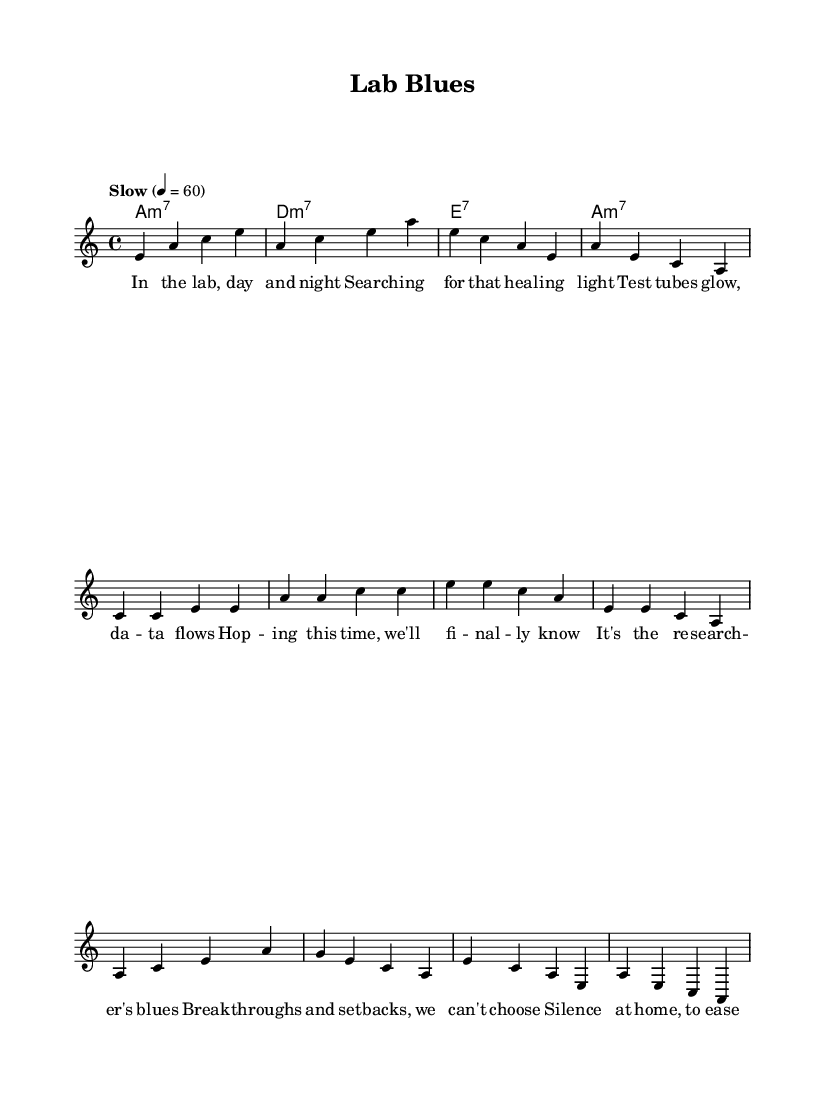What is the key signature of this music? The key signature is indicated at the beginning of the sheet music. It shows that the piece is in A minor, which has no sharps or flats.
Answer: A minor What is the time signature of this piece? The time signature is found at the beginning of the staff. It indicates that the piece has a 4/4 time signature, meaning there are four beats in a measure and the quarter note receives one beat.
Answer: 4/4 What is the tempo marking for this music? The tempo marking is specified above the staff as "Slow", and it indicates that the piece should be played at a speed of 60 beats per minute.
Answer: Slow How many measures are there in the verse? To determine the number of measures in the verse, we count each segment between the vertical lines. The verse consists of four measures.
Answer: Four What is the chord used in the chorus? The chord used in the chorus can be found in the chord section. The first chord played in the chorus is A minor 7, which corresponds to the melody line.
Answer: A minor 7 What unique structure does this blues piece possess? The unique structure of blues music typically includes a 12-bar form; however, this piece follows a pattern that emphasizes melancholic themes and lyrics instead of the traditional 12-bar format, with repeated chorus.
Answer: Melancholic themes and repeated chorus 